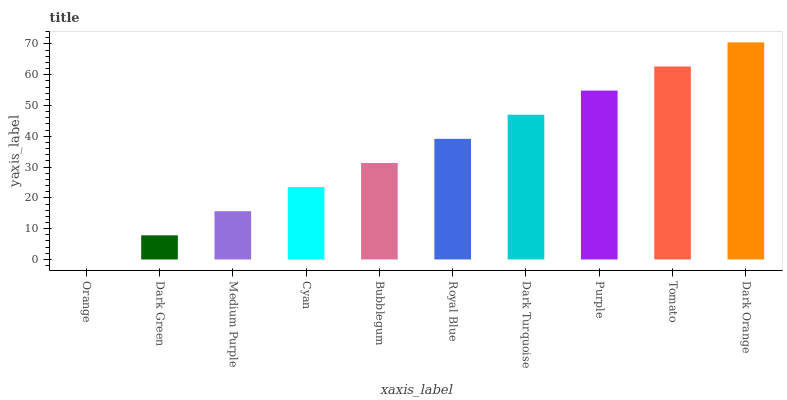Is Dark Green the minimum?
Answer yes or no. No. Is Dark Green the maximum?
Answer yes or no. No. Is Dark Green greater than Orange?
Answer yes or no. Yes. Is Orange less than Dark Green?
Answer yes or no. Yes. Is Orange greater than Dark Green?
Answer yes or no. No. Is Dark Green less than Orange?
Answer yes or no. No. Is Royal Blue the high median?
Answer yes or no. Yes. Is Bubblegum the low median?
Answer yes or no. Yes. Is Tomato the high median?
Answer yes or no. No. Is Tomato the low median?
Answer yes or no. No. 